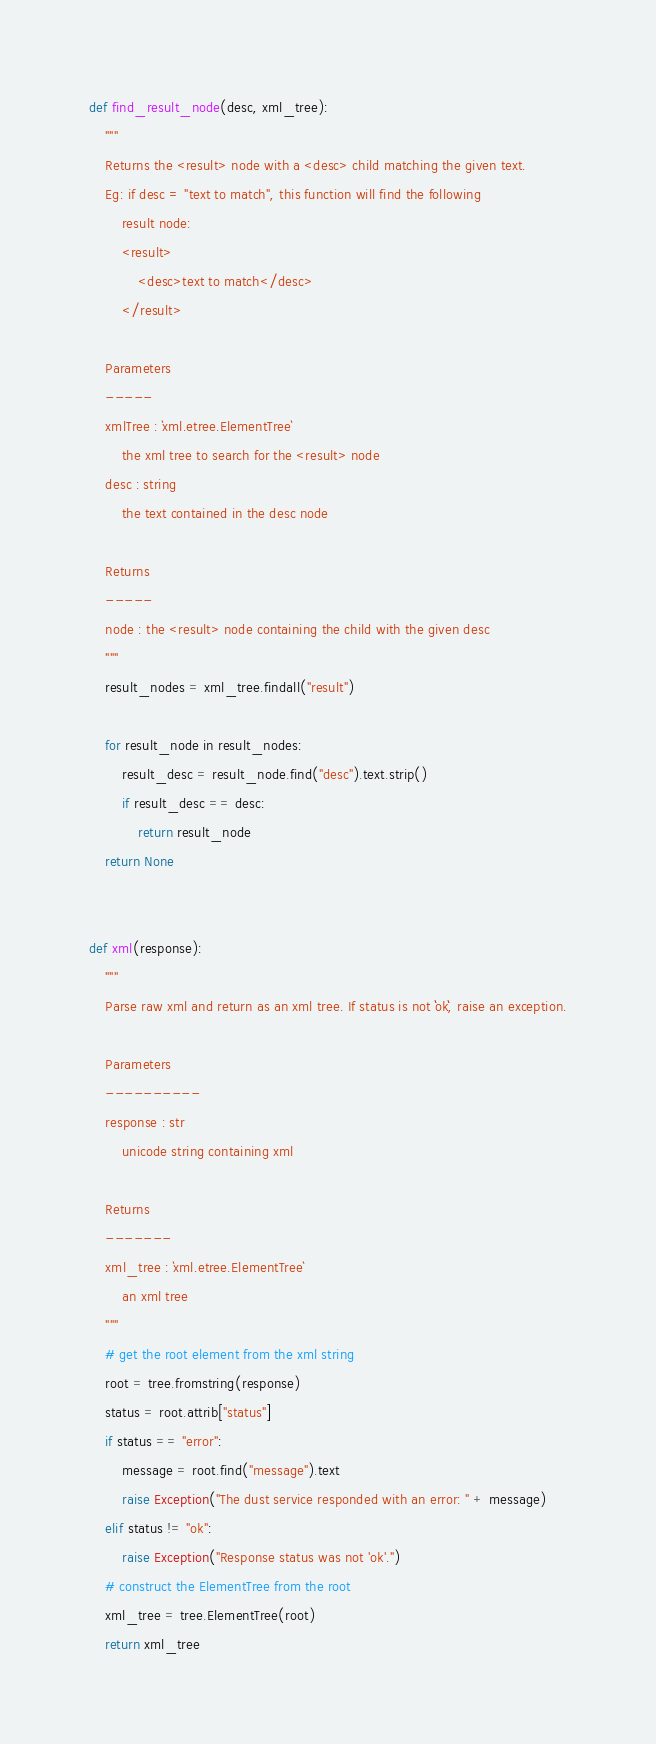Convert code to text. <code><loc_0><loc_0><loc_500><loc_500><_Python_>
def find_result_node(desc, xml_tree):
    """
    Returns the <result> node with a <desc> child matching the given text.
    Eg: if desc = "text to match", this function will find the following
        result node:
        <result>
            <desc>text to match</desc>
        </result>

    Parameters
    -----
    xmlTree : `xml.etree.ElementTree`
        the xml tree to search for the <result> node
    desc : string
        the text contained in the desc node

    Returns
    -----
    node : the <result> node containing the child with the given desc
    """
    result_nodes = xml_tree.findall("result")

    for result_node in result_nodes:
        result_desc = result_node.find("desc").text.strip()
        if result_desc == desc:
            return result_node
    return None


def xml(response):
    """
    Parse raw xml and return as an xml tree. If status is not ``ok``, raise an exception.

    Parameters
    ----------
    response : str
        unicode string containing xml

    Returns
    -------
    xml_tree : `xml.etree.ElementTree`
        an xml tree
    """
    # get the root element from the xml string
    root = tree.fromstring(response)
    status = root.attrib["status"]
    if status == "error":
        message = root.find("message").text
        raise Exception("The dust service responded with an error: " + message)
    elif status != "ok":
        raise Exception("Response status was not 'ok'.")
    # construct the ElementTree from the root
    xml_tree = tree.ElementTree(root)
    return xml_tree
</code> 